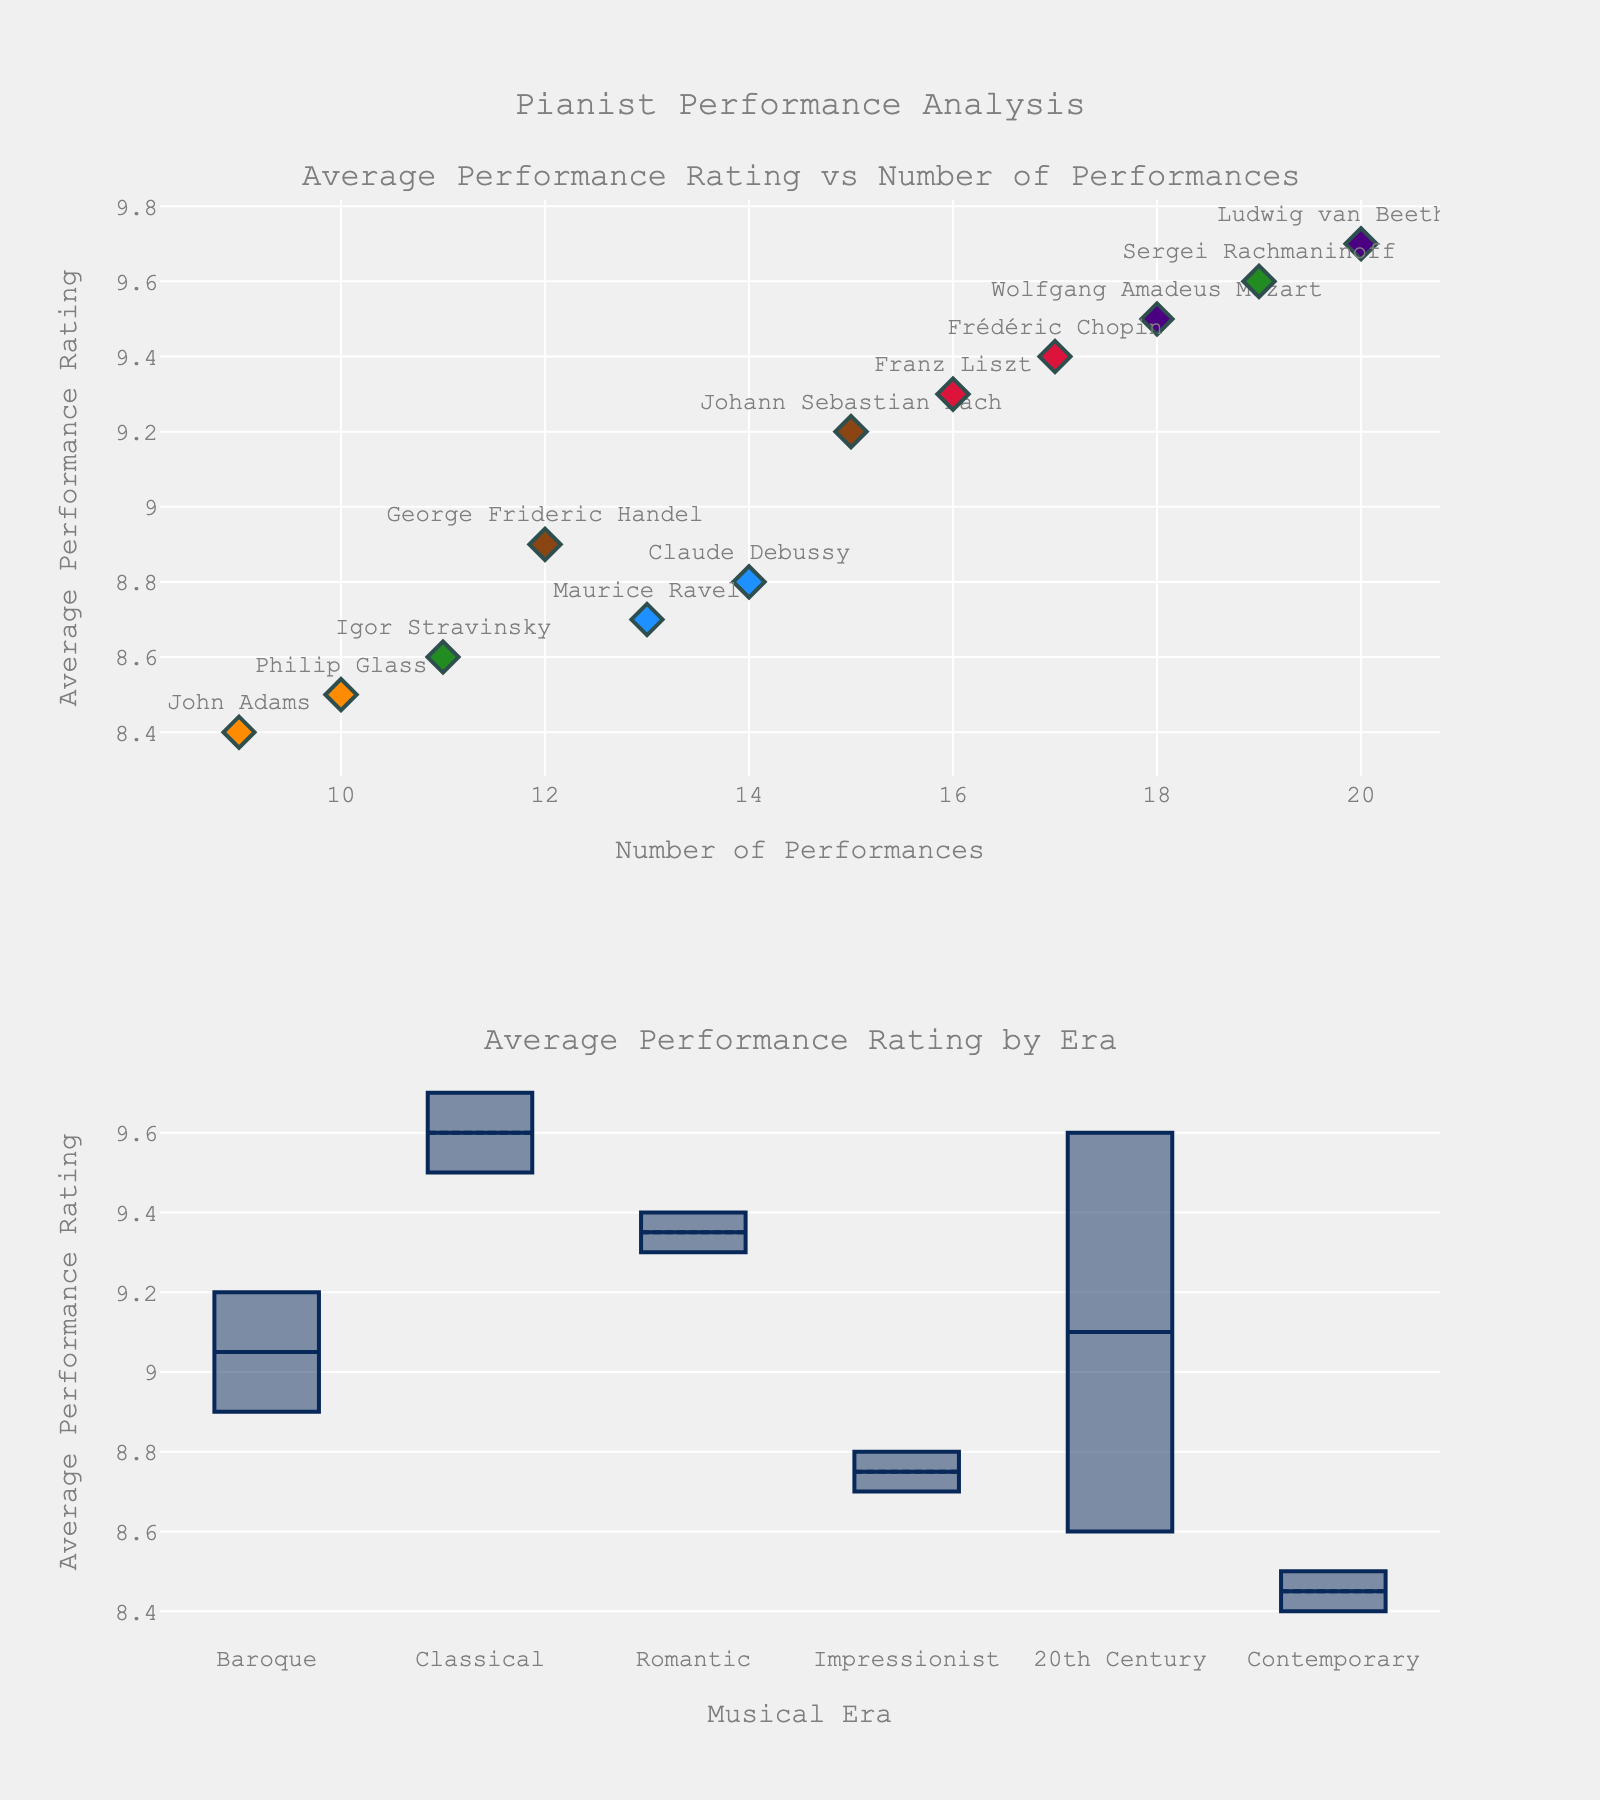What's the title of the figure? Refer to the title visible at the top of the figure. It clearly states the main focus of the analysis.
Answer: Pianist Performance Analysis Which era has the highest average performance rating on the scatter plot? Look at the scatter plot in the first row and identify the era with the highest placed data point.
Answer: 20th Century Who is the pianist with the highest number of performances in the Classical era? Find the data points for the Classical era in the scatter plot, then identify the pianist with the highest number on the x-axis.
Answer: Ludwig van Beethoven What is the range of average performance ratings in the Romantic era based on the box plot? The box plot for the Romantic era shows the minimum and maximum values; the range is the difference between these two values.
Answer: 9.3 to 9.4 How many eras have pianists with an average performance rating above 9? Count the unique eras with data points above the horizontal threshold of 9 in both plots.
Answer: Four What's the difference in the average performance rating between the highest and lowest rated pianists? Identify the highest and lowest ratings in the scatter plot, then subtract the lowest from the highest rating.
Answer: 9.7 - 8.4 = 1.3 Who are the pianists included in the Impressionist era? Look at the scatter plot and box plot labels specifically for the Impressionist era to identify the names.
Answer: Claude Debussy and Maurice Ravel Which pianist has the lowest average performance rating, and what is it? Identify the data point with the lowest position on the y-axis and its corresponding label in the scatter plot.
Answer: John Adams with 8.4 Is there a correlation between the number of performances and the average performance rating? Examine the scatter plot to see if there is any visible trend or pattern between the x-axis (number of performances) and the y-axis (performance rating).
Answer: No clear correlation Which era has the widest range in performance ratings, and how is it determined in the box plot? The widest range can be seen by comparing the lengths of the boxes and whiskers across different eras in the box plot. Longer boxes and whiskers indicate a wider range.
Answer: Contemporary with the widest box 